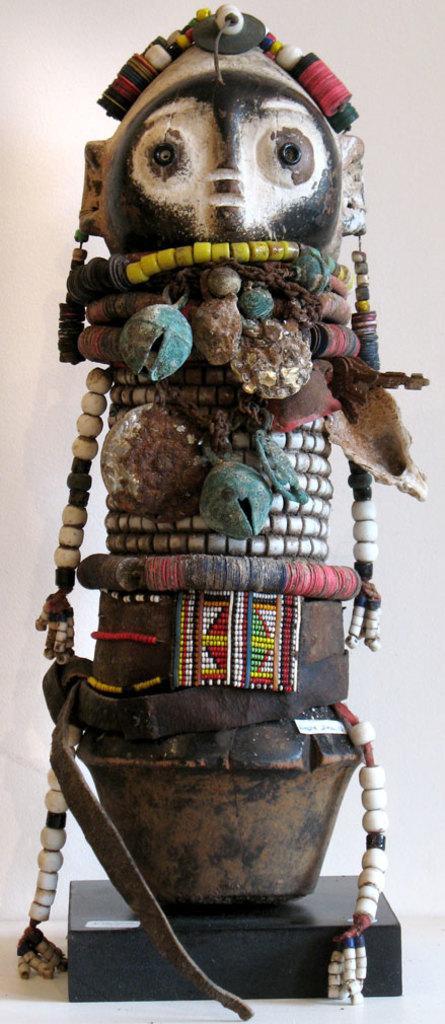Can you describe this image briefly? In this image we can see statue. 